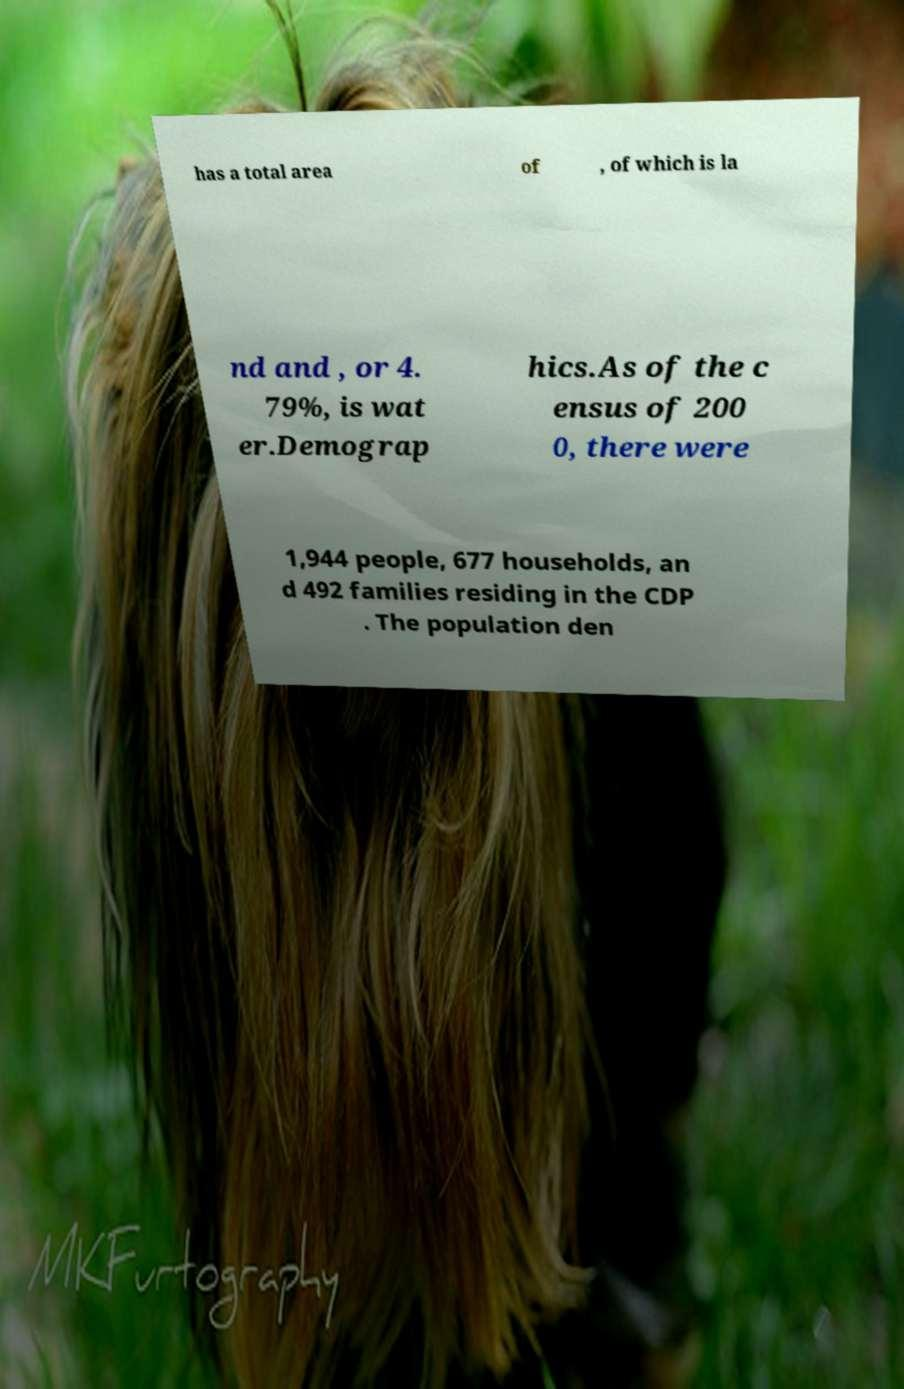Can you read and provide the text displayed in the image?This photo seems to have some interesting text. Can you extract and type it out for me? has a total area of , of which is la nd and , or 4. 79%, is wat er.Demograp hics.As of the c ensus of 200 0, there were 1,944 people, 677 households, an d 492 families residing in the CDP . The population den 